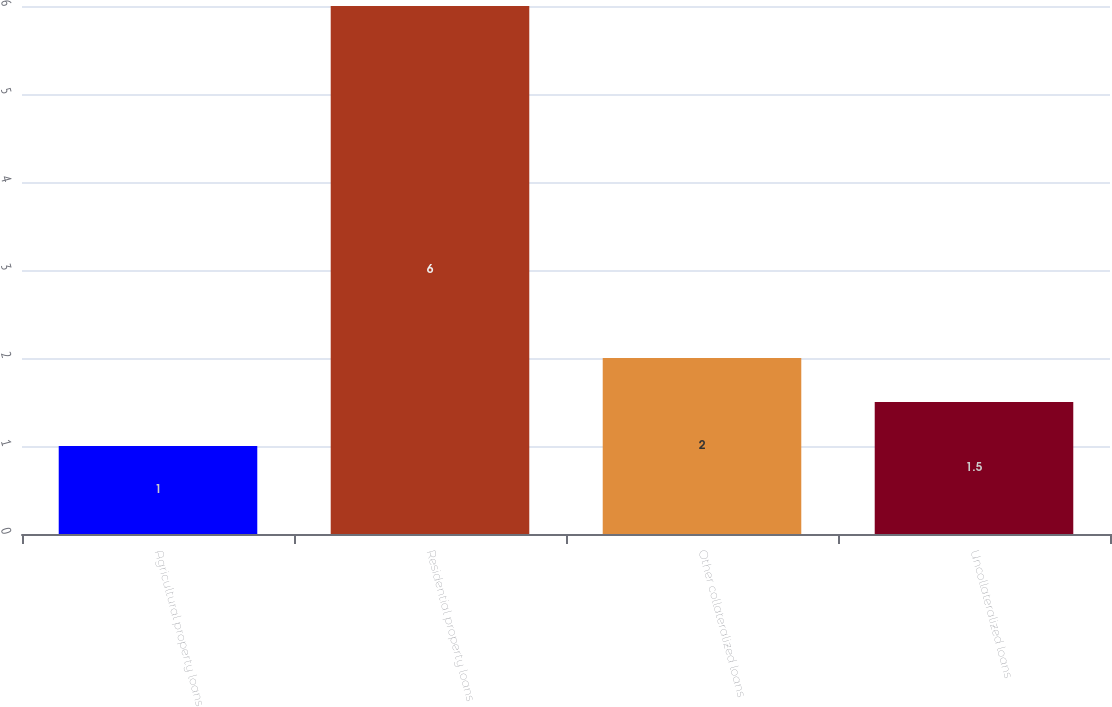<chart> <loc_0><loc_0><loc_500><loc_500><bar_chart><fcel>Agricultural property loans<fcel>Residential property loans<fcel>Other collateralized loans<fcel>Uncollateralized loans<nl><fcel>1<fcel>6<fcel>2<fcel>1.5<nl></chart> 